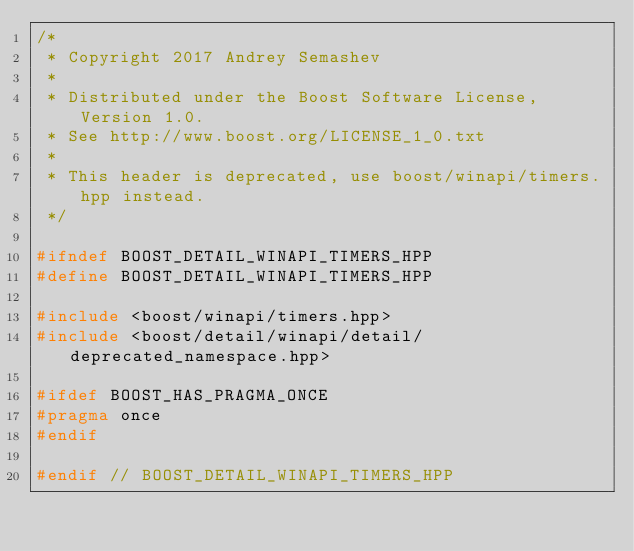<code> <loc_0><loc_0><loc_500><loc_500><_C++_>/*
 * Copyright 2017 Andrey Semashev
 *
 * Distributed under the Boost Software License, Version 1.0.
 * See http://www.boost.org/LICENSE_1_0.txt
 *
 * This header is deprecated, use boost/winapi/timers.hpp instead.
 */

#ifndef BOOST_DETAIL_WINAPI_TIMERS_HPP
#define BOOST_DETAIL_WINAPI_TIMERS_HPP

#include <boost/winapi/timers.hpp>
#include <boost/detail/winapi/detail/deprecated_namespace.hpp>

#ifdef BOOST_HAS_PRAGMA_ONCE
#pragma once
#endif

#endif // BOOST_DETAIL_WINAPI_TIMERS_HPP
</code> 